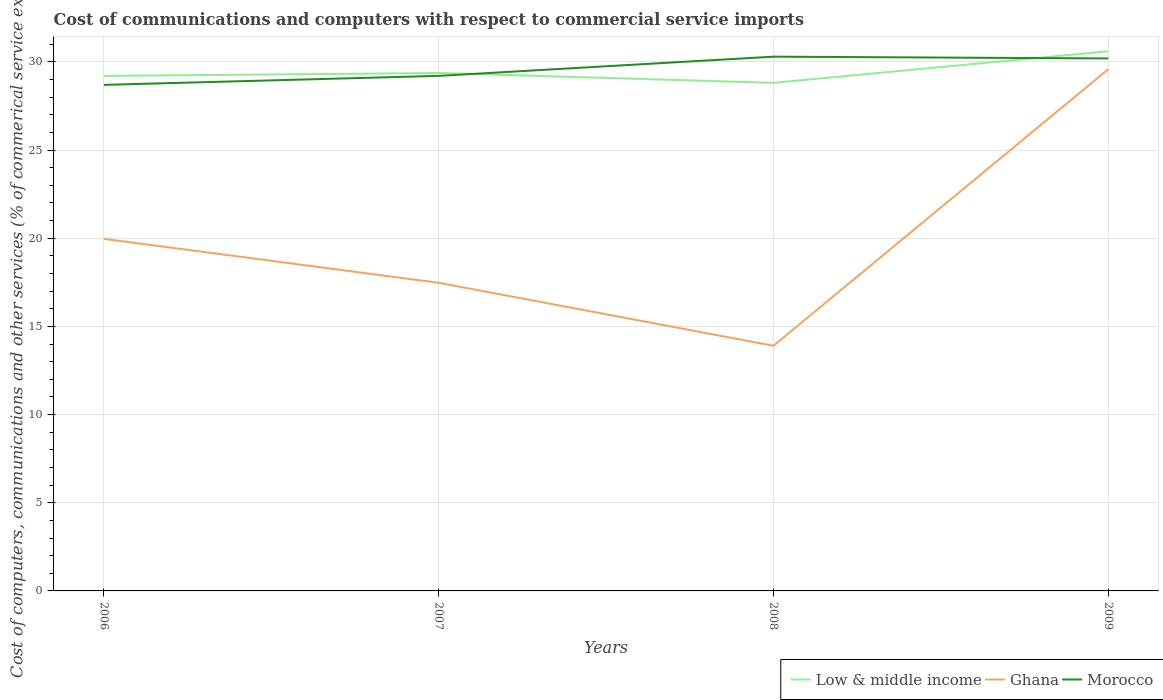How many different coloured lines are there?
Offer a very short reply. 3. Across all years, what is the maximum cost of communications and computers in Low & middle income?
Provide a short and direct response. 28.81. In which year was the cost of communications and computers in Ghana maximum?
Give a very brief answer. 2008. What is the total cost of communications and computers in Ghana in the graph?
Offer a terse response. 2.49. What is the difference between the highest and the second highest cost of communications and computers in Low & middle income?
Ensure brevity in your answer.  1.79. Is the cost of communications and computers in Low & middle income strictly greater than the cost of communications and computers in Morocco over the years?
Offer a terse response. No. How many years are there in the graph?
Provide a succinct answer. 4. What is the difference between two consecutive major ticks on the Y-axis?
Provide a succinct answer. 5. Where does the legend appear in the graph?
Your response must be concise. Bottom right. How are the legend labels stacked?
Make the answer very short. Horizontal. What is the title of the graph?
Your answer should be very brief. Cost of communications and computers with respect to commercial service imports. What is the label or title of the Y-axis?
Your answer should be very brief. Cost of computers, communications and other services (% of commerical service exports). What is the Cost of computers, communications and other services (% of commerical service exports) in Low & middle income in 2006?
Keep it short and to the point. 29.2. What is the Cost of computers, communications and other services (% of commerical service exports) of Ghana in 2006?
Your answer should be very brief. 19.96. What is the Cost of computers, communications and other services (% of commerical service exports) in Morocco in 2006?
Offer a terse response. 28.69. What is the Cost of computers, communications and other services (% of commerical service exports) in Low & middle income in 2007?
Offer a very short reply. 29.37. What is the Cost of computers, communications and other services (% of commerical service exports) of Ghana in 2007?
Your answer should be compact. 17.47. What is the Cost of computers, communications and other services (% of commerical service exports) of Morocco in 2007?
Your response must be concise. 29.2. What is the Cost of computers, communications and other services (% of commerical service exports) in Low & middle income in 2008?
Your response must be concise. 28.81. What is the Cost of computers, communications and other services (% of commerical service exports) in Ghana in 2008?
Make the answer very short. 13.9. What is the Cost of computers, communications and other services (% of commerical service exports) of Morocco in 2008?
Keep it short and to the point. 30.29. What is the Cost of computers, communications and other services (% of commerical service exports) of Low & middle income in 2009?
Offer a very short reply. 30.6. What is the Cost of computers, communications and other services (% of commerical service exports) of Ghana in 2009?
Your answer should be very brief. 29.58. What is the Cost of computers, communications and other services (% of commerical service exports) of Morocco in 2009?
Provide a short and direct response. 30.19. Across all years, what is the maximum Cost of computers, communications and other services (% of commerical service exports) in Low & middle income?
Offer a very short reply. 30.6. Across all years, what is the maximum Cost of computers, communications and other services (% of commerical service exports) in Ghana?
Make the answer very short. 29.58. Across all years, what is the maximum Cost of computers, communications and other services (% of commerical service exports) in Morocco?
Your answer should be compact. 30.29. Across all years, what is the minimum Cost of computers, communications and other services (% of commerical service exports) in Low & middle income?
Provide a short and direct response. 28.81. Across all years, what is the minimum Cost of computers, communications and other services (% of commerical service exports) of Ghana?
Ensure brevity in your answer.  13.9. Across all years, what is the minimum Cost of computers, communications and other services (% of commerical service exports) in Morocco?
Ensure brevity in your answer.  28.69. What is the total Cost of computers, communications and other services (% of commerical service exports) in Low & middle income in the graph?
Provide a short and direct response. 117.97. What is the total Cost of computers, communications and other services (% of commerical service exports) in Ghana in the graph?
Provide a succinct answer. 80.91. What is the total Cost of computers, communications and other services (% of commerical service exports) of Morocco in the graph?
Your answer should be very brief. 118.38. What is the difference between the Cost of computers, communications and other services (% of commerical service exports) in Low & middle income in 2006 and that in 2007?
Your answer should be compact. -0.16. What is the difference between the Cost of computers, communications and other services (% of commerical service exports) of Ghana in 2006 and that in 2007?
Your answer should be very brief. 2.49. What is the difference between the Cost of computers, communications and other services (% of commerical service exports) in Morocco in 2006 and that in 2007?
Your answer should be very brief. -0.51. What is the difference between the Cost of computers, communications and other services (% of commerical service exports) in Low & middle income in 2006 and that in 2008?
Keep it short and to the point. 0.39. What is the difference between the Cost of computers, communications and other services (% of commerical service exports) of Ghana in 2006 and that in 2008?
Your answer should be very brief. 6.06. What is the difference between the Cost of computers, communications and other services (% of commerical service exports) in Low & middle income in 2006 and that in 2009?
Keep it short and to the point. -1.4. What is the difference between the Cost of computers, communications and other services (% of commerical service exports) in Ghana in 2006 and that in 2009?
Your answer should be compact. -9.62. What is the difference between the Cost of computers, communications and other services (% of commerical service exports) in Morocco in 2006 and that in 2009?
Ensure brevity in your answer.  -1.5. What is the difference between the Cost of computers, communications and other services (% of commerical service exports) in Low & middle income in 2007 and that in 2008?
Make the answer very short. 0.56. What is the difference between the Cost of computers, communications and other services (% of commerical service exports) of Ghana in 2007 and that in 2008?
Your response must be concise. 3.57. What is the difference between the Cost of computers, communications and other services (% of commerical service exports) of Morocco in 2007 and that in 2008?
Make the answer very short. -1.09. What is the difference between the Cost of computers, communications and other services (% of commerical service exports) in Low & middle income in 2007 and that in 2009?
Provide a succinct answer. -1.23. What is the difference between the Cost of computers, communications and other services (% of commerical service exports) of Ghana in 2007 and that in 2009?
Offer a terse response. -12.11. What is the difference between the Cost of computers, communications and other services (% of commerical service exports) in Morocco in 2007 and that in 2009?
Your answer should be compact. -0.99. What is the difference between the Cost of computers, communications and other services (% of commerical service exports) of Low & middle income in 2008 and that in 2009?
Keep it short and to the point. -1.79. What is the difference between the Cost of computers, communications and other services (% of commerical service exports) in Ghana in 2008 and that in 2009?
Provide a short and direct response. -15.68. What is the difference between the Cost of computers, communications and other services (% of commerical service exports) of Morocco in 2008 and that in 2009?
Provide a succinct answer. 0.1. What is the difference between the Cost of computers, communications and other services (% of commerical service exports) in Low & middle income in 2006 and the Cost of computers, communications and other services (% of commerical service exports) in Ghana in 2007?
Give a very brief answer. 11.73. What is the difference between the Cost of computers, communications and other services (% of commerical service exports) in Low & middle income in 2006 and the Cost of computers, communications and other services (% of commerical service exports) in Morocco in 2007?
Ensure brevity in your answer.  -0. What is the difference between the Cost of computers, communications and other services (% of commerical service exports) in Ghana in 2006 and the Cost of computers, communications and other services (% of commerical service exports) in Morocco in 2007?
Keep it short and to the point. -9.24. What is the difference between the Cost of computers, communications and other services (% of commerical service exports) of Low & middle income in 2006 and the Cost of computers, communications and other services (% of commerical service exports) of Ghana in 2008?
Your response must be concise. 15.3. What is the difference between the Cost of computers, communications and other services (% of commerical service exports) in Low & middle income in 2006 and the Cost of computers, communications and other services (% of commerical service exports) in Morocco in 2008?
Offer a very short reply. -1.09. What is the difference between the Cost of computers, communications and other services (% of commerical service exports) of Ghana in 2006 and the Cost of computers, communications and other services (% of commerical service exports) of Morocco in 2008?
Your answer should be compact. -10.33. What is the difference between the Cost of computers, communications and other services (% of commerical service exports) in Low & middle income in 2006 and the Cost of computers, communications and other services (% of commerical service exports) in Ghana in 2009?
Your answer should be very brief. -0.38. What is the difference between the Cost of computers, communications and other services (% of commerical service exports) in Low & middle income in 2006 and the Cost of computers, communications and other services (% of commerical service exports) in Morocco in 2009?
Provide a succinct answer. -0.99. What is the difference between the Cost of computers, communications and other services (% of commerical service exports) of Ghana in 2006 and the Cost of computers, communications and other services (% of commerical service exports) of Morocco in 2009?
Offer a very short reply. -10.23. What is the difference between the Cost of computers, communications and other services (% of commerical service exports) in Low & middle income in 2007 and the Cost of computers, communications and other services (% of commerical service exports) in Ghana in 2008?
Offer a terse response. 15.46. What is the difference between the Cost of computers, communications and other services (% of commerical service exports) in Low & middle income in 2007 and the Cost of computers, communications and other services (% of commerical service exports) in Morocco in 2008?
Your answer should be compact. -0.93. What is the difference between the Cost of computers, communications and other services (% of commerical service exports) in Ghana in 2007 and the Cost of computers, communications and other services (% of commerical service exports) in Morocco in 2008?
Provide a short and direct response. -12.82. What is the difference between the Cost of computers, communications and other services (% of commerical service exports) in Low & middle income in 2007 and the Cost of computers, communications and other services (% of commerical service exports) in Ghana in 2009?
Your answer should be compact. -0.21. What is the difference between the Cost of computers, communications and other services (% of commerical service exports) of Low & middle income in 2007 and the Cost of computers, communications and other services (% of commerical service exports) of Morocco in 2009?
Offer a terse response. -0.83. What is the difference between the Cost of computers, communications and other services (% of commerical service exports) in Ghana in 2007 and the Cost of computers, communications and other services (% of commerical service exports) in Morocco in 2009?
Give a very brief answer. -12.72. What is the difference between the Cost of computers, communications and other services (% of commerical service exports) in Low & middle income in 2008 and the Cost of computers, communications and other services (% of commerical service exports) in Ghana in 2009?
Ensure brevity in your answer.  -0.77. What is the difference between the Cost of computers, communications and other services (% of commerical service exports) in Low & middle income in 2008 and the Cost of computers, communications and other services (% of commerical service exports) in Morocco in 2009?
Give a very brief answer. -1.38. What is the difference between the Cost of computers, communications and other services (% of commerical service exports) in Ghana in 2008 and the Cost of computers, communications and other services (% of commerical service exports) in Morocco in 2009?
Make the answer very short. -16.29. What is the average Cost of computers, communications and other services (% of commerical service exports) of Low & middle income per year?
Ensure brevity in your answer.  29.49. What is the average Cost of computers, communications and other services (% of commerical service exports) in Ghana per year?
Provide a succinct answer. 20.23. What is the average Cost of computers, communications and other services (% of commerical service exports) of Morocco per year?
Provide a short and direct response. 29.6. In the year 2006, what is the difference between the Cost of computers, communications and other services (% of commerical service exports) in Low & middle income and Cost of computers, communications and other services (% of commerical service exports) in Ghana?
Ensure brevity in your answer.  9.24. In the year 2006, what is the difference between the Cost of computers, communications and other services (% of commerical service exports) of Low & middle income and Cost of computers, communications and other services (% of commerical service exports) of Morocco?
Your answer should be compact. 0.51. In the year 2006, what is the difference between the Cost of computers, communications and other services (% of commerical service exports) in Ghana and Cost of computers, communications and other services (% of commerical service exports) in Morocco?
Your response must be concise. -8.73. In the year 2007, what is the difference between the Cost of computers, communications and other services (% of commerical service exports) of Low & middle income and Cost of computers, communications and other services (% of commerical service exports) of Ghana?
Make the answer very short. 11.9. In the year 2007, what is the difference between the Cost of computers, communications and other services (% of commerical service exports) of Low & middle income and Cost of computers, communications and other services (% of commerical service exports) of Morocco?
Keep it short and to the point. 0.16. In the year 2007, what is the difference between the Cost of computers, communications and other services (% of commerical service exports) of Ghana and Cost of computers, communications and other services (% of commerical service exports) of Morocco?
Your answer should be compact. -11.73. In the year 2008, what is the difference between the Cost of computers, communications and other services (% of commerical service exports) of Low & middle income and Cost of computers, communications and other services (% of commerical service exports) of Ghana?
Your answer should be very brief. 14.91. In the year 2008, what is the difference between the Cost of computers, communications and other services (% of commerical service exports) of Low & middle income and Cost of computers, communications and other services (% of commerical service exports) of Morocco?
Ensure brevity in your answer.  -1.48. In the year 2008, what is the difference between the Cost of computers, communications and other services (% of commerical service exports) in Ghana and Cost of computers, communications and other services (% of commerical service exports) in Morocco?
Provide a succinct answer. -16.39. In the year 2009, what is the difference between the Cost of computers, communications and other services (% of commerical service exports) of Low & middle income and Cost of computers, communications and other services (% of commerical service exports) of Ghana?
Your response must be concise. 1.02. In the year 2009, what is the difference between the Cost of computers, communications and other services (% of commerical service exports) in Low & middle income and Cost of computers, communications and other services (% of commerical service exports) in Morocco?
Keep it short and to the point. 0.41. In the year 2009, what is the difference between the Cost of computers, communications and other services (% of commerical service exports) in Ghana and Cost of computers, communications and other services (% of commerical service exports) in Morocco?
Offer a terse response. -0.61. What is the ratio of the Cost of computers, communications and other services (% of commerical service exports) of Low & middle income in 2006 to that in 2007?
Provide a short and direct response. 0.99. What is the ratio of the Cost of computers, communications and other services (% of commerical service exports) in Ghana in 2006 to that in 2007?
Your response must be concise. 1.14. What is the ratio of the Cost of computers, communications and other services (% of commerical service exports) of Morocco in 2006 to that in 2007?
Give a very brief answer. 0.98. What is the ratio of the Cost of computers, communications and other services (% of commerical service exports) of Low & middle income in 2006 to that in 2008?
Provide a short and direct response. 1.01. What is the ratio of the Cost of computers, communications and other services (% of commerical service exports) of Ghana in 2006 to that in 2008?
Your answer should be compact. 1.44. What is the ratio of the Cost of computers, communications and other services (% of commerical service exports) in Morocco in 2006 to that in 2008?
Provide a succinct answer. 0.95. What is the ratio of the Cost of computers, communications and other services (% of commerical service exports) in Low & middle income in 2006 to that in 2009?
Provide a succinct answer. 0.95. What is the ratio of the Cost of computers, communications and other services (% of commerical service exports) in Ghana in 2006 to that in 2009?
Provide a short and direct response. 0.67. What is the ratio of the Cost of computers, communications and other services (% of commerical service exports) of Morocco in 2006 to that in 2009?
Your answer should be compact. 0.95. What is the ratio of the Cost of computers, communications and other services (% of commerical service exports) in Low & middle income in 2007 to that in 2008?
Your answer should be very brief. 1.02. What is the ratio of the Cost of computers, communications and other services (% of commerical service exports) of Ghana in 2007 to that in 2008?
Your answer should be compact. 1.26. What is the ratio of the Cost of computers, communications and other services (% of commerical service exports) in Low & middle income in 2007 to that in 2009?
Provide a short and direct response. 0.96. What is the ratio of the Cost of computers, communications and other services (% of commerical service exports) of Ghana in 2007 to that in 2009?
Your response must be concise. 0.59. What is the ratio of the Cost of computers, communications and other services (% of commerical service exports) of Morocco in 2007 to that in 2009?
Provide a succinct answer. 0.97. What is the ratio of the Cost of computers, communications and other services (% of commerical service exports) in Low & middle income in 2008 to that in 2009?
Your answer should be compact. 0.94. What is the ratio of the Cost of computers, communications and other services (% of commerical service exports) in Ghana in 2008 to that in 2009?
Your response must be concise. 0.47. What is the ratio of the Cost of computers, communications and other services (% of commerical service exports) in Morocco in 2008 to that in 2009?
Offer a very short reply. 1. What is the difference between the highest and the second highest Cost of computers, communications and other services (% of commerical service exports) in Low & middle income?
Offer a very short reply. 1.23. What is the difference between the highest and the second highest Cost of computers, communications and other services (% of commerical service exports) in Ghana?
Provide a short and direct response. 9.62. What is the difference between the highest and the second highest Cost of computers, communications and other services (% of commerical service exports) of Morocco?
Your response must be concise. 0.1. What is the difference between the highest and the lowest Cost of computers, communications and other services (% of commerical service exports) in Low & middle income?
Make the answer very short. 1.79. What is the difference between the highest and the lowest Cost of computers, communications and other services (% of commerical service exports) in Ghana?
Make the answer very short. 15.68. 